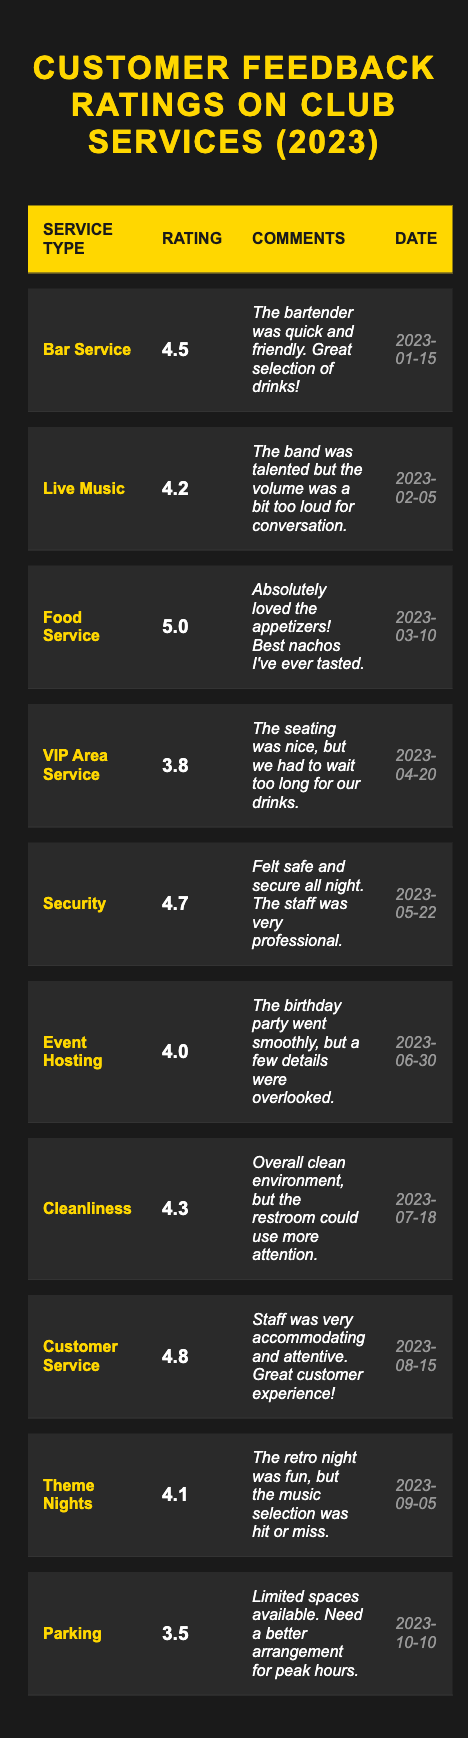What is the highest rating service in the table? The highest rating in the table is for "Food Service," which has a rating of 5.0.
Answer: Food Service How many services have a rating of 4.5 or higher? There are 6 services with a rating of 4.5 or higher: Bar Service (4.5), Food Service (5.0), Security (4.7), Customer Service (4.8), and Event Hosting (4.0).
Answer: 6 Which service received the lowest rating? The lowest rating is for "Parking," which has a rating of 3.5.
Answer: Parking Is the average rating of all services above 4.0? The average rating is calculated by summing all ratings (4.5 + 4.2 + 5.0 + 3.8 + 4.7 + 4.0 + 4.3 + 4.8 + 4.1 + 3.5) = 4.26. Since 4.26 is above 4.0, the answer is yes.
Answer: Yes What is the difference in rating between the best and worst rated service? The best rating is 5.0 (Food Service) and the worst rating is 3.5 (Parking). The difference is calculated by subtracting: 5.0 - 3.5 = 1.5.
Answer: 1.5 Which service type had the highest customer satisfaction based on comments? "Customer Service" had very positive comments, stating that the staff was "very accommodating and attentive," indicating high satisfaction.
Answer: Customer Service What percentage of services have a rating below 4.0? There are 10 services in total, and 3 services have a rating below 4.0 (VIP Area Service 3.8, Parking 3.5). The percentage is calculated as (3/10) * 100 = 30%.
Answer: 30% List one comment for any service type that received a rating of 4.0 or less. For "VIP Area Service," the comment is: "The seating was nice, but we had to wait too long for our drinks."
Answer: VIP Area Service comment Which service had the earliest date mentioned in the table? The earliest date in the table is "2023-01-15," which corresponds to "Bar Service."
Answer: Bar Service Is there any service that received exactly a rating of 4.0? Yes, "Event Hosting" received a rating of exactly 4.0.
Answer: Yes 